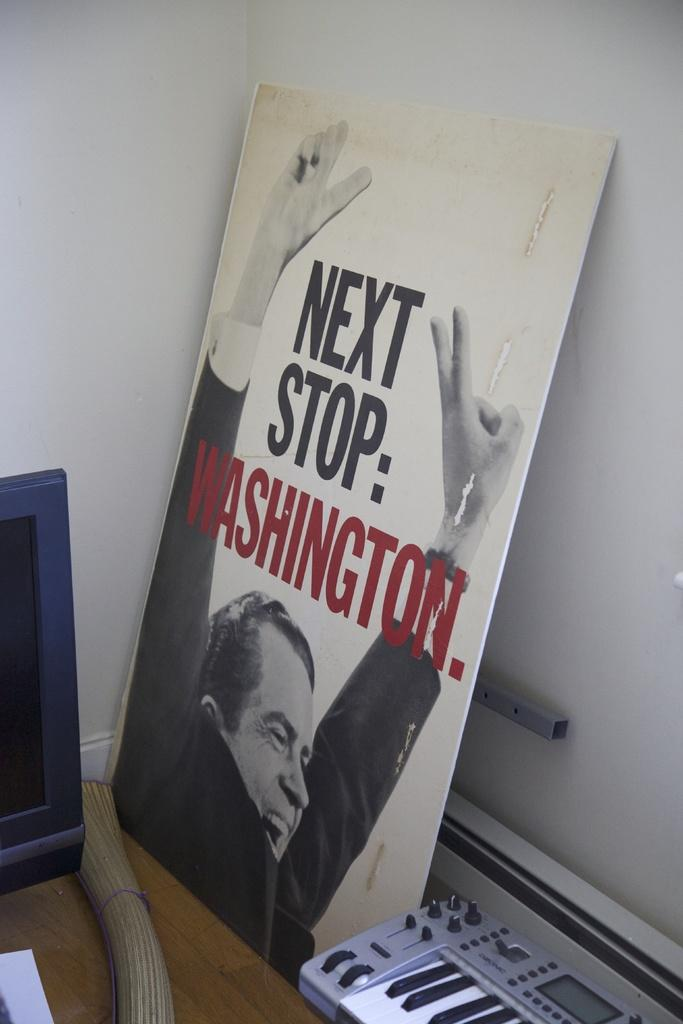What is the color of the wall in the image? The wall in the image is white. What object can be seen on the table in the image? There is a book on the table in the image. What type of reaction can be seen from the key in the image? There is no key present in the image, so it is not possible to determine any reaction from a key. 